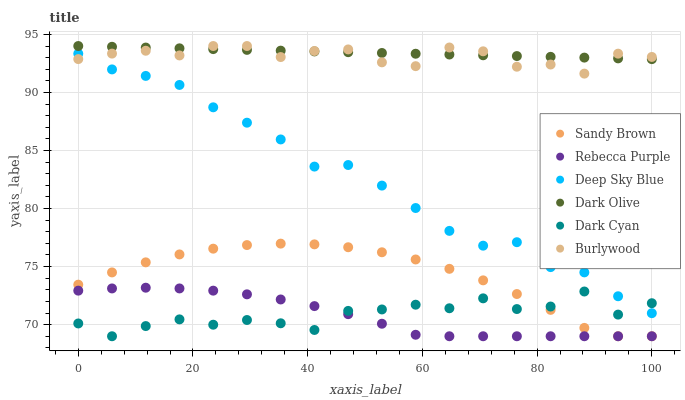Does Rebecca Purple have the minimum area under the curve?
Answer yes or no. Yes. Does Dark Olive have the maximum area under the curve?
Answer yes or no. Yes. Does Dark Olive have the minimum area under the curve?
Answer yes or no. No. Does Rebecca Purple have the maximum area under the curve?
Answer yes or no. No. Is Dark Olive the smoothest?
Answer yes or no. Yes. Is Dark Cyan the roughest?
Answer yes or no. Yes. Is Rebecca Purple the smoothest?
Answer yes or no. No. Is Rebecca Purple the roughest?
Answer yes or no. No. Does Rebecca Purple have the lowest value?
Answer yes or no. Yes. Does Dark Olive have the lowest value?
Answer yes or no. No. Does Dark Olive have the highest value?
Answer yes or no. Yes. Does Rebecca Purple have the highest value?
Answer yes or no. No. Is Sandy Brown less than Burlywood?
Answer yes or no. Yes. Is Burlywood greater than Sandy Brown?
Answer yes or no. Yes. Does Dark Cyan intersect Sandy Brown?
Answer yes or no. Yes. Is Dark Cyan less than Sandy Brown?
Answer yes or no. No. Is Dark Cyan greater than Sandy Brown?
Answer yes or no. No. Does Sandy Brown intersect Burlywood?
Answer yes or no. No. 